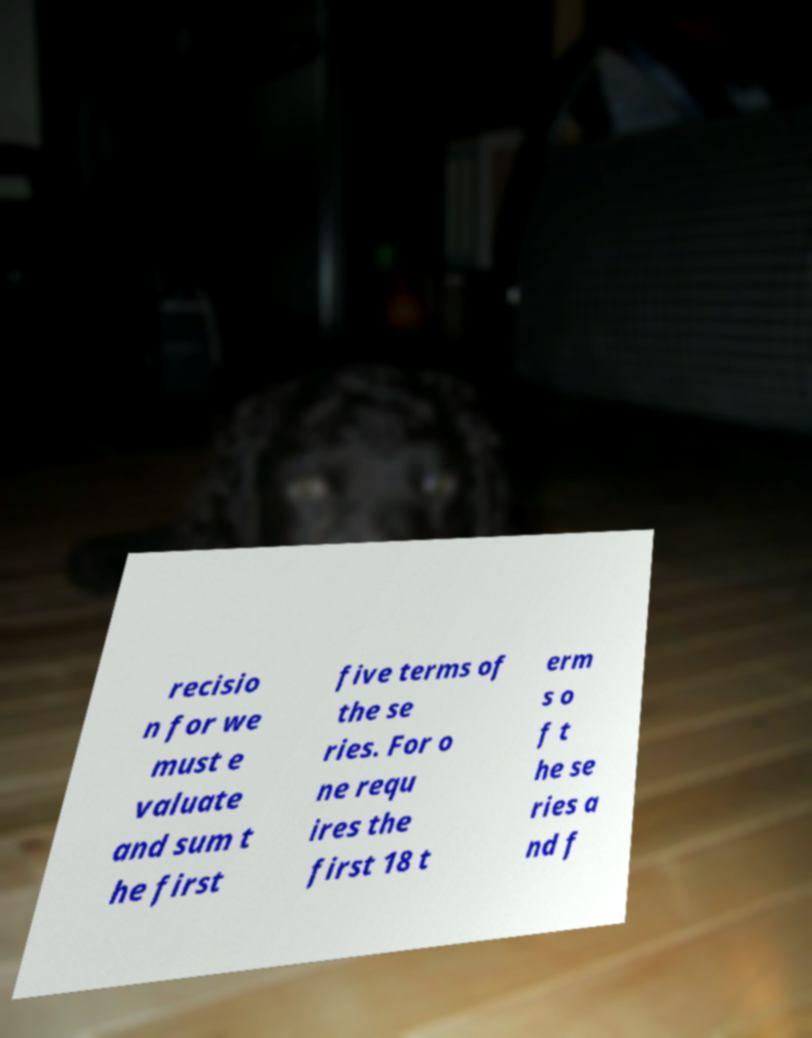Please identify and transcribe the text found in this image. recisio n for we must e valuate and sum t he first five terms of the se ries. For o ne requ ires the first 18 t erm s o f t he se ries a nd f 